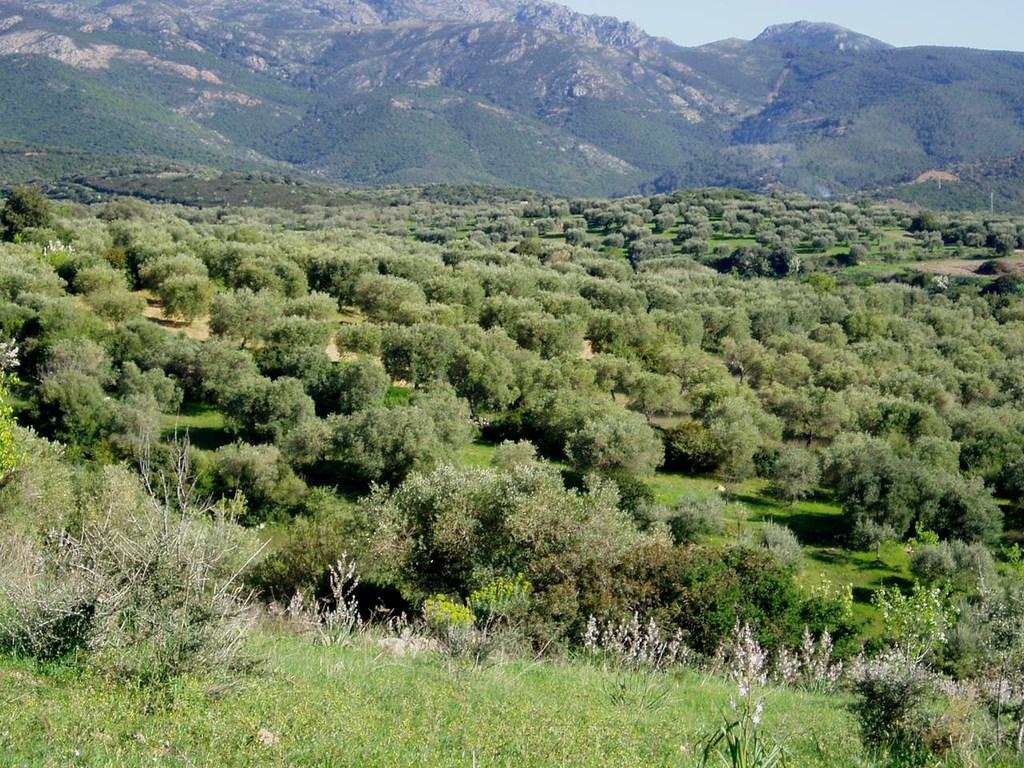Describe this image in one or two sentences. In this picture I can see trees, hills, at the top right corner of the image I can see the sky. 